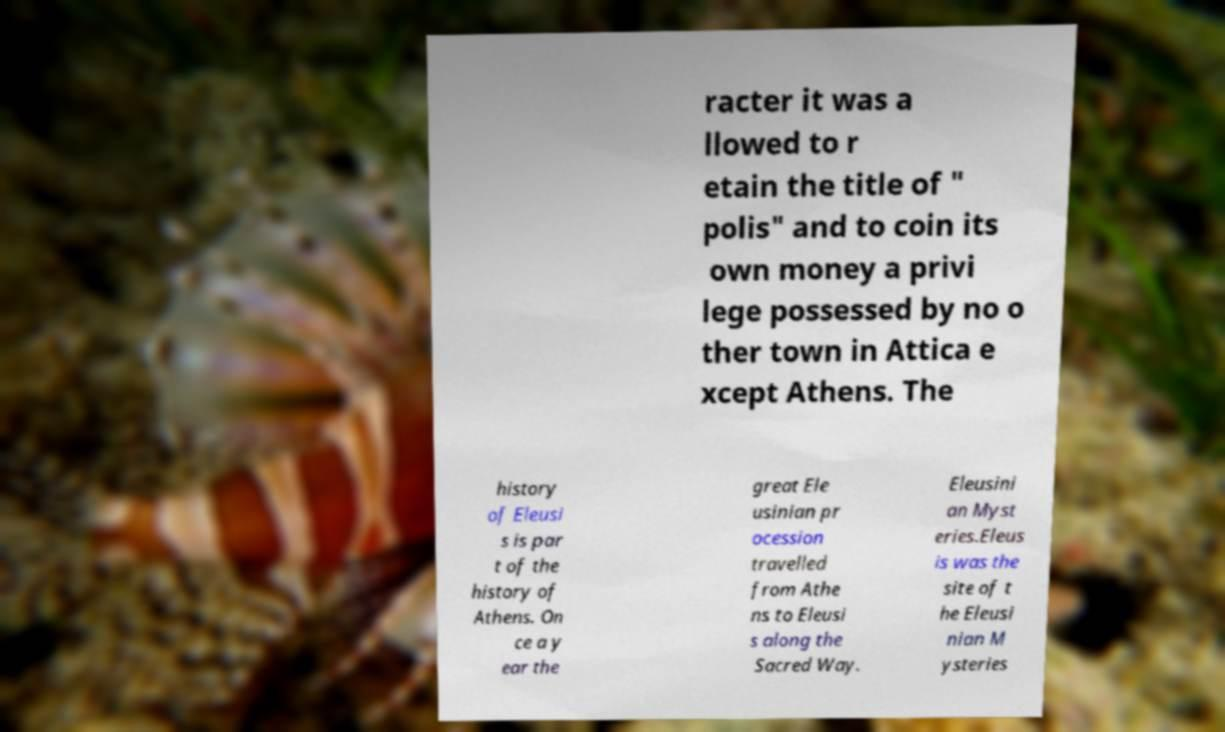Please identify and transcribe the text found in this image. racter it was a llowed to r etain the title of " polis" and to coin its own money a privi lege possessed by no o ther town in Attica e xcept Athens. The history of Eleusi s is par t of the history of Athens. On ce a y ear the great Ele usinian pr ocession travelled from Athe ns to Eleusi s along the Sacred Way. Eleusini an Myst eries.Eleus is was the site of t he Eleusi nian M ysteries 